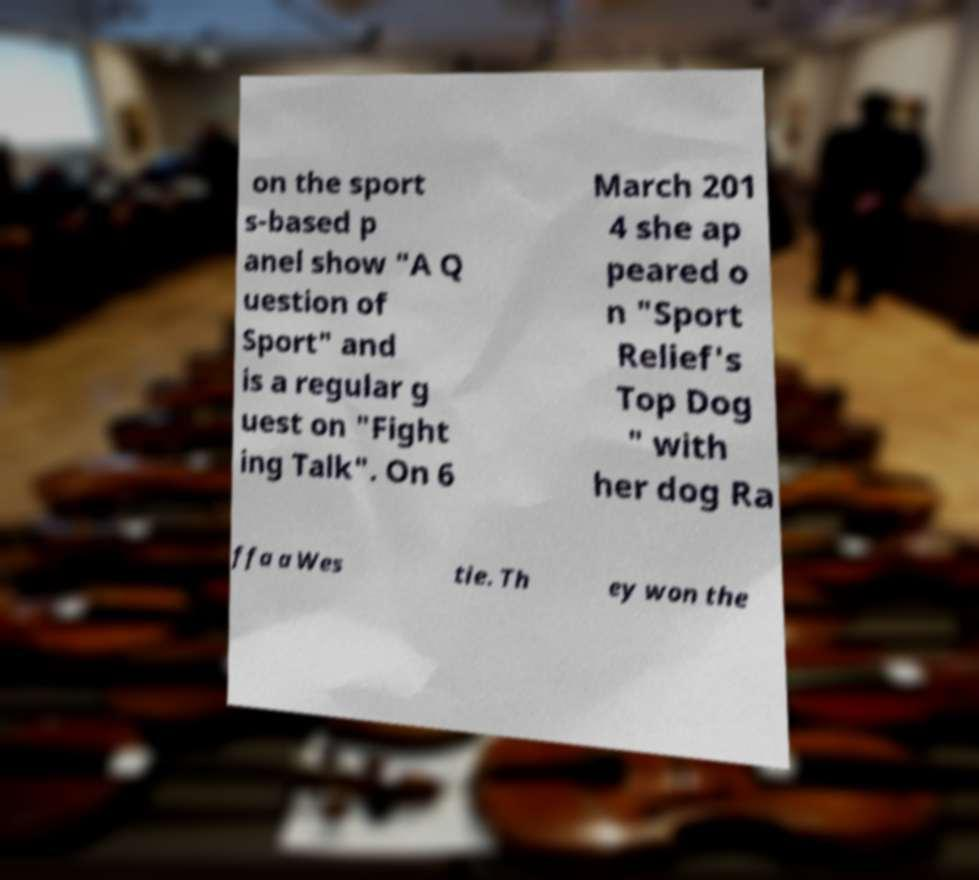There's text embedded in this image that I need extracted. Can you transcribe it verbatim? on the sport s-based p anel show "A Q uestion of Sport" and is a regular g uest on "Fight ing Talk". On 6 March 201 4 she ap peared o n "Sport Relief's Top Dog " with her dog Ra ffa a Wes tie. Th ey won the 